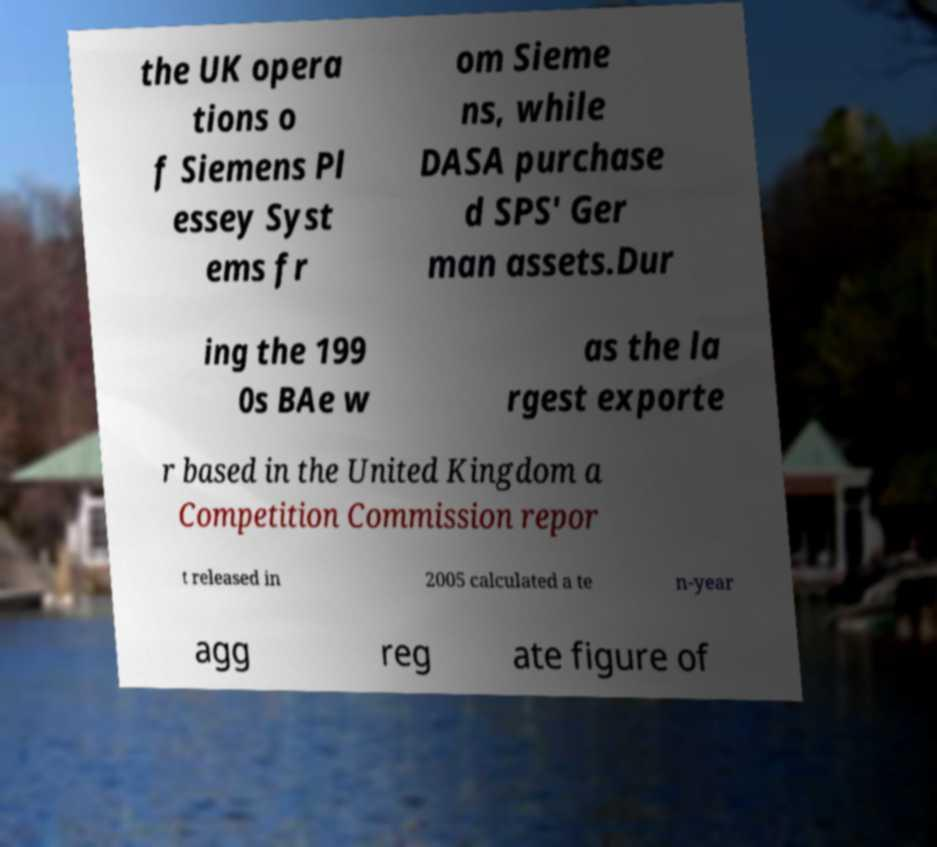Could you assist in decoding the text presented in this image and type it out clearly? the UK opera tions o f Siemens Pl essey Syst ems fr om Sieme ns, while DASA purchase d SPS' Ger man assets.Dur ing the 199 0s BAe w as the la rgest exporte r based in the United Kingdom a Competition Commission repor t released in 2005 calculated a te n-year agg reg ate figure of 